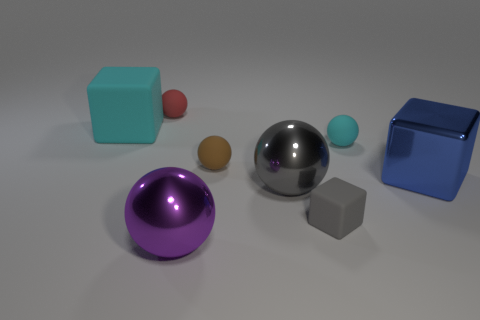Does the small object in front of the big blue thing have the same shape as the big thing behind the blue metal block? yes 